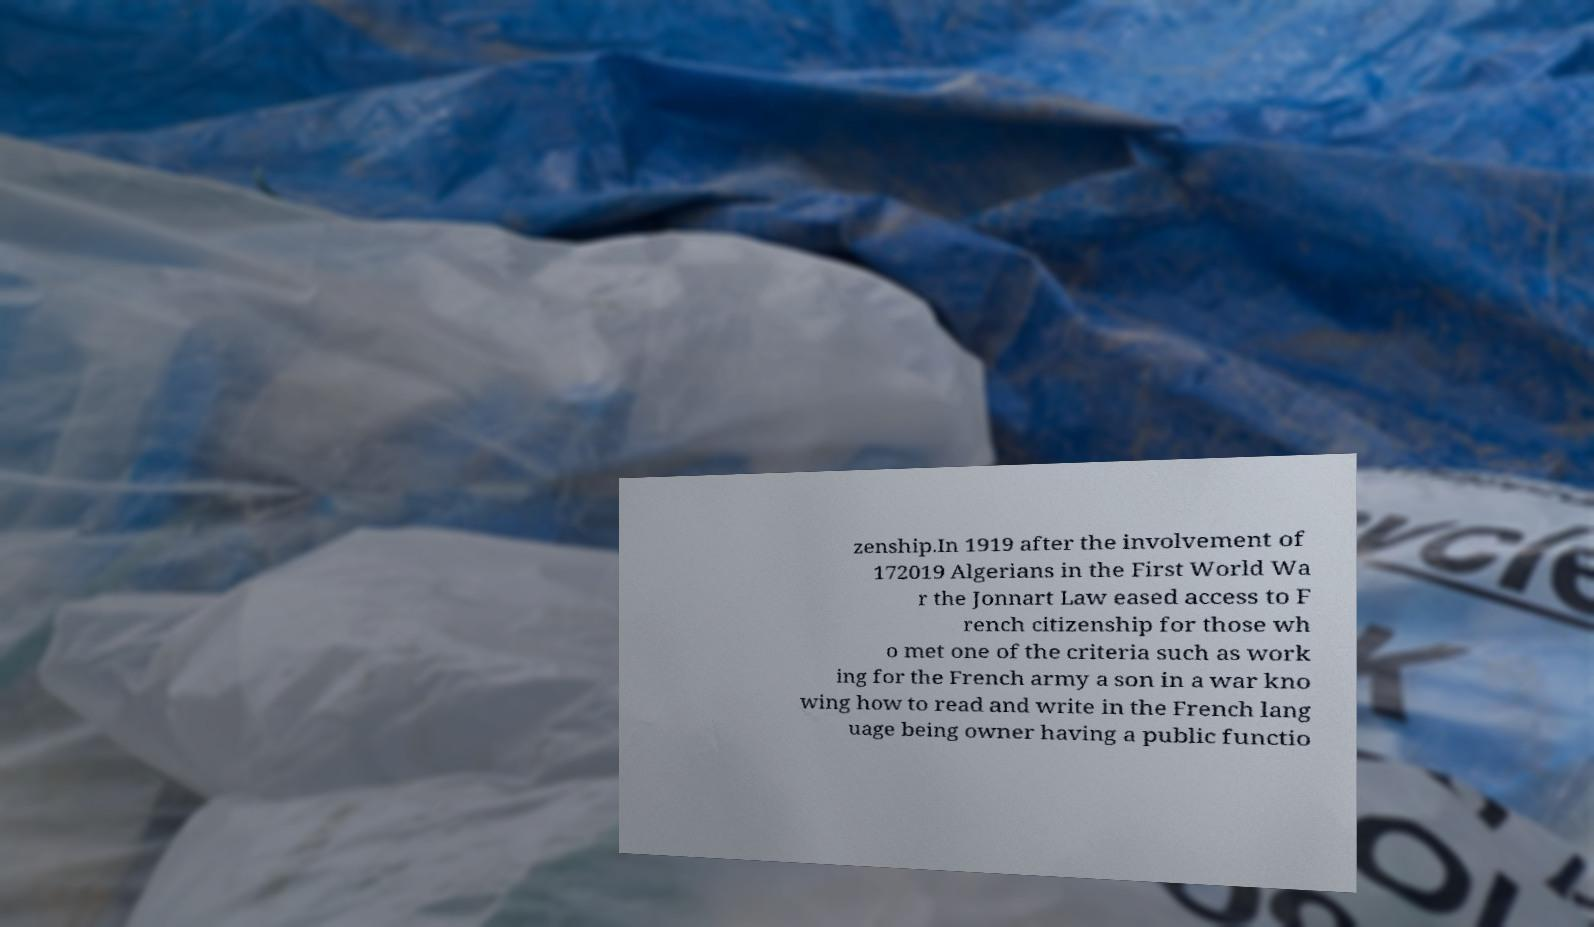I need the written content from this picture converted into text. Can you do that? zenship.In 1919 after the involvement of 172019 Algerians in the First World Wa r the Jonnart Law eased access to F rench citizenship for those wh o met one of the criteria such as work ing for the French army a son in a war kno wing how to read and write in the French lang uage being owner having a public functio 